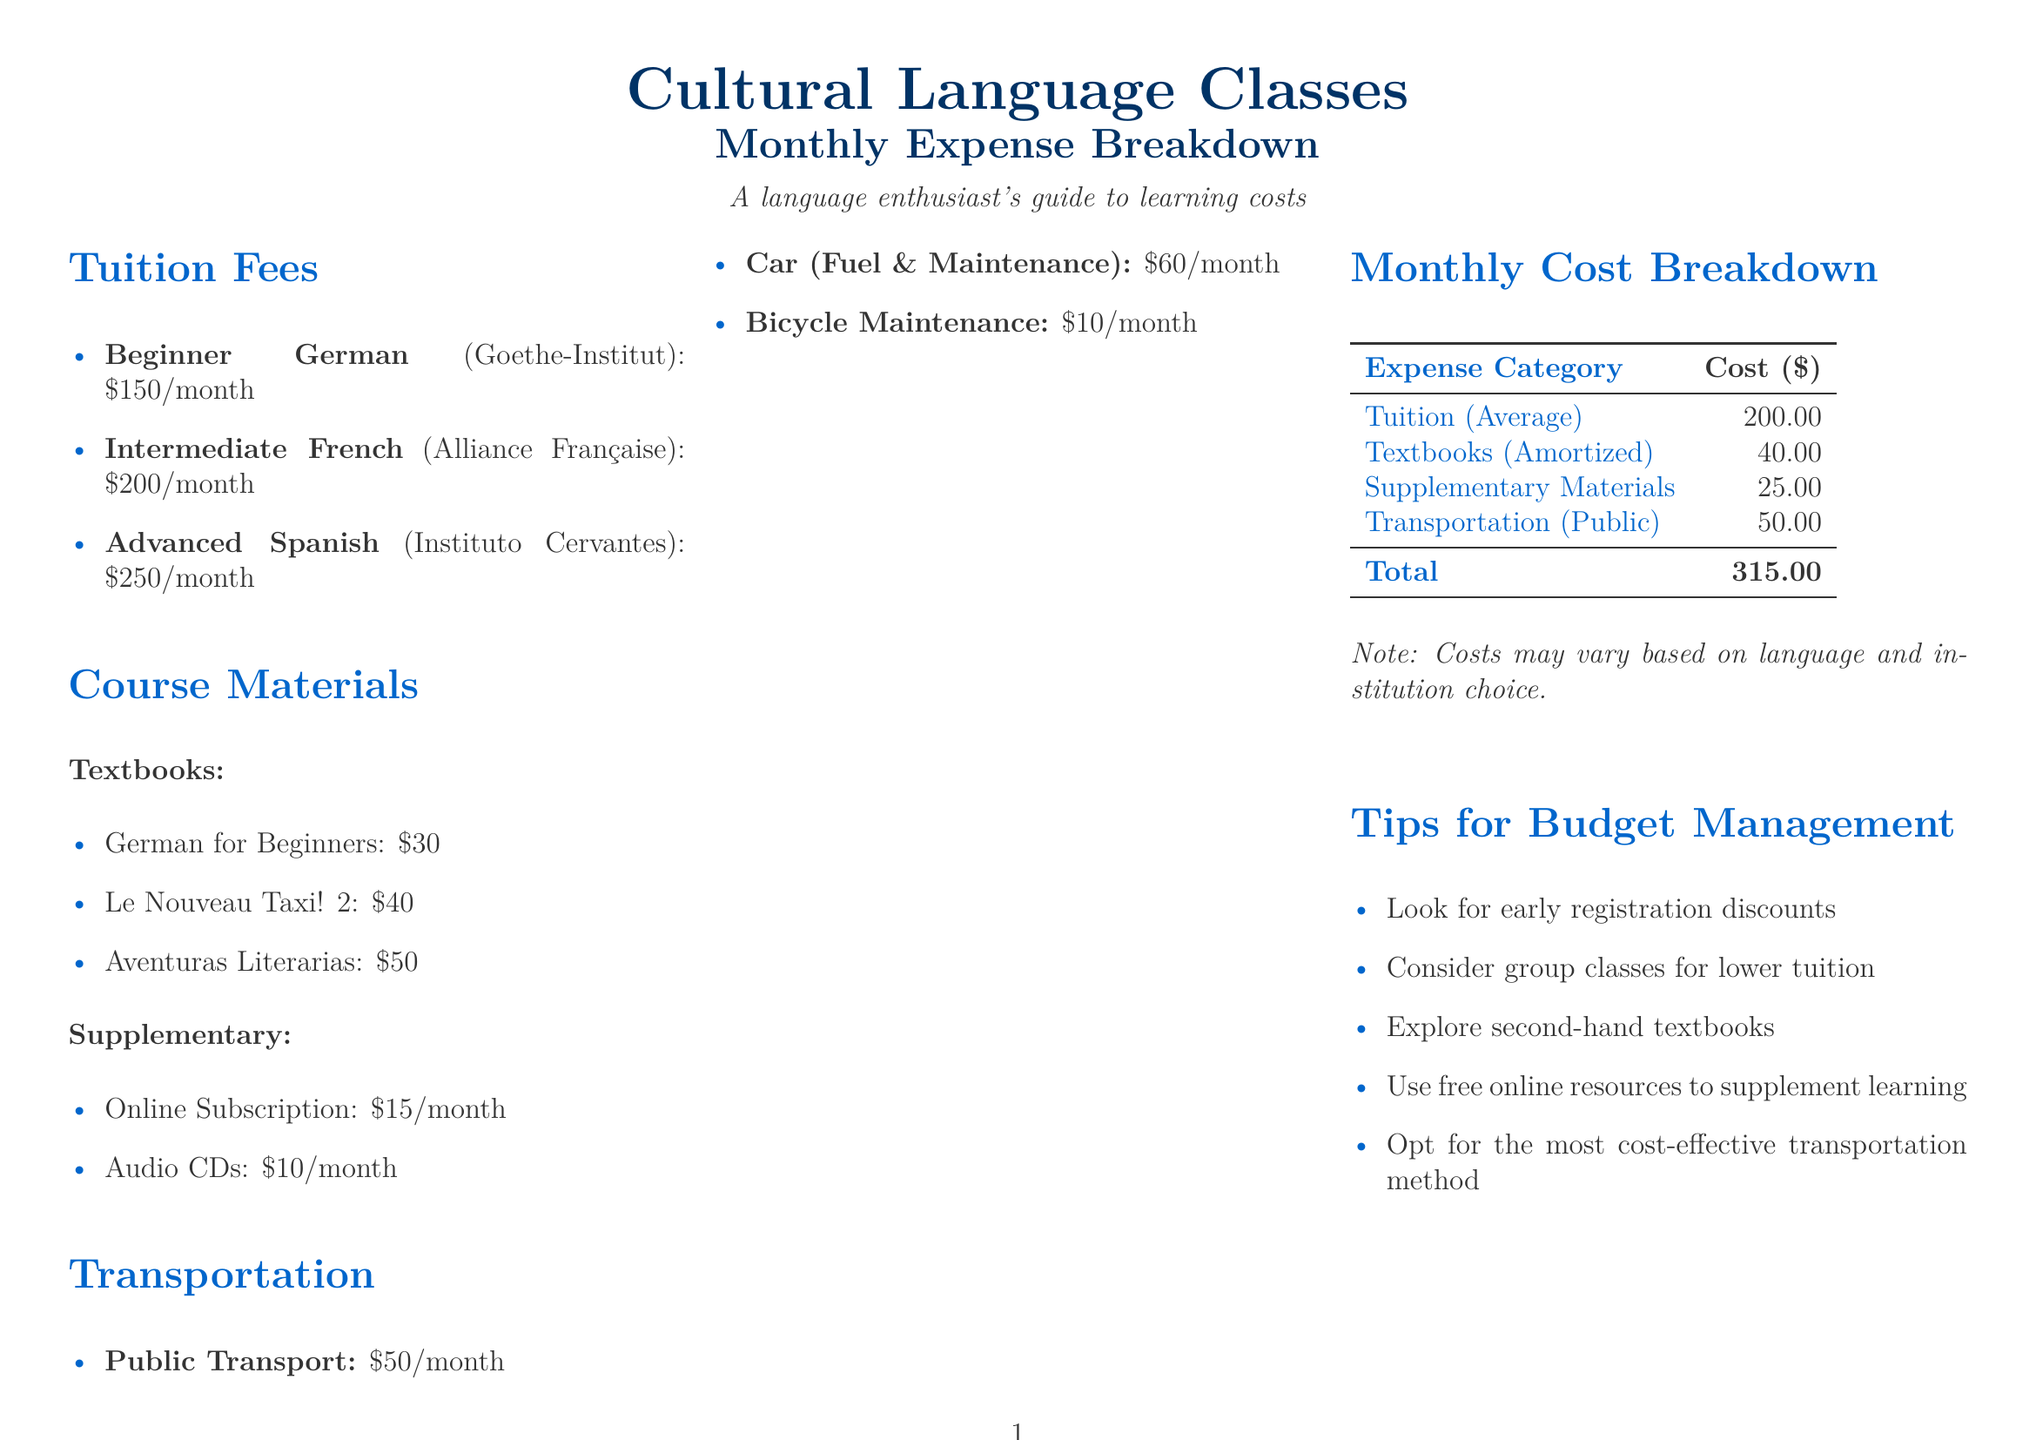What is the average tuition fee? The average tuition fee is calculated from the listed tuition fees in the document, which comes to $200.00.
Answer: $200.00 How much do textbooks for language classes cost? The document lists the costs of textbooks, showing a total of $120 for all three books.
Answer: $120 What is the monthly cost for public transport? The document explicitly states that the cost for public transport is $50/month.
Answer: $50 Which language class has the highest tuition fee? By comparing the listed tuition fees, the Advanced Spanish class has the highest tuition fee of $250/month.
Answer: Advanced Spanish What is the total monthly cost for attending language classes? The total monthly cost is determined by adding up all the expenses mentioned, which amounts to $315.00.
Answer: $315.00 What is one tip provided for budget management? The document includes various tips for budget management, one such tip suggests looking for early registration discounts.
Answer: Look for early registration discounts Which language is associated with the Goethe-Institut? The Goethe-Institut is specifically associated with Beginner German classes.
Answer: Beginner German What are the benefits of learning a language mentioned in the document? The benefits include several aspects, one of which is improved career prospects.
Answer: Improved career prospects 